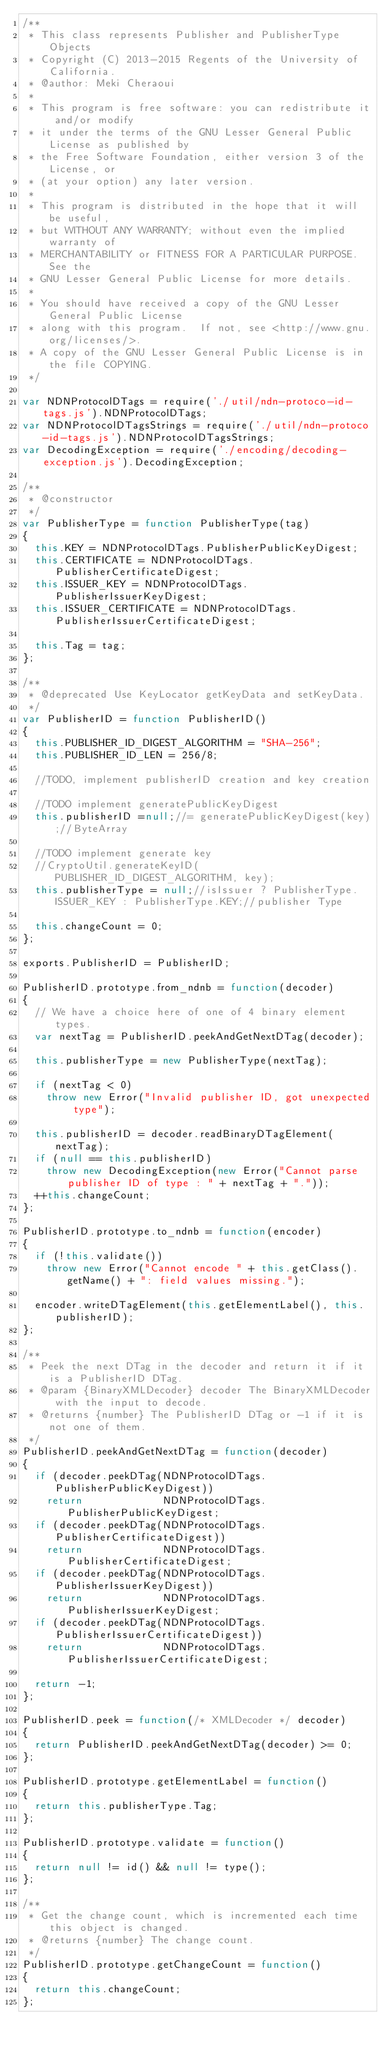Convert code to text. <code><loc_0><loc_0><loc_500><loc_500><_JavaScript_>/**
 * This class represents Publisher and PublisherType Objects
 * Copyright (C) 2013-2015 Regents of the University of California.
 * @author: Meki Cheraoui
 *
 * This program is free software: you can redistribute it and/or modify
 * it under the terms of the GNU Lesser General Public License as published by
 * the Free Software Foundation, either version 3 of the License, or
 * (at your option) any later version.
 *
 * This program is distributed in the hope that it will be useful,
 * but WITHOUT ANY WARRANTY; without even the implied warranty of
 * MERCHANTABILITY or FITNESS FOR A PARTICULAR PURPOSE.  See the
 * GNU Lesser General Public License for more details.
 *
 * You should have received a copy of the GNU Lesser General Public License
 * along with this program.  If not, see <http://www.gnu.org/licenses/>.
 * A copy of the GNU Lesser General Public License is in the file COPYING.
 */

var NDNProtocolDTags = require('./util/ndn-protoco-id-tags.js').NDNProtocolDTags;
var NDNProtocolDTagsStrings = require('./util/ndn-protoco-id-tags.js').NDNProtocolDTagsStrings;
var DecodingException = require('./encoding/decoding-exception.js').DecodingException;

/**
 * @constructor
 */
var PublisherType = function PublisherType(tag)
{
  this.KEY = NDNProtocolDTags.PublisherPublicKeyDigest;
  this.CERTIFICATE = NDNProtocolDTags.PublisherCertificateDigest;
  this.ISSUER_KEY = NDNProtocolDTags.PublisherIssuerKeyDigest;
  this.ISSUER_CERTIFICATE = NDNProtocolDTags.PublisherIssuerCertificateDigest;

  this.Tag = tag;
};

/**
 * @deprecated Use KeyLocator getKeyData and setKeyData.
 */
var PublisherID = function PublisherID()
{
  this.PUBLISHER_ID_DIGEST_ALGORITHM = "SHA-256";
  this.PUBLISHER_ID_LEN = 256/8;

  //TODO, implement publisherID creation and key creation

  //TODO implement generatePublicKeyDigest
  this.publisherID =null;//= generatePublicKeyDigest(key);//ByteArray

  //TODO implement generate key
  //CryptoUtil.generateKeyID(PUBLISHER_ID_DIGEST_ALGORITHM, key);
  this.publisherType = null;//isIssuer ? PublisherType.ISSUER_KEY : PublisherType.KEY;//publisher Type

  this.changeCount = 0;
};

exports.PublisherID = PublisherID;

PublisherID.prototype.from_ndnb = function(decoder)
{
  // We have a choice here of one of 4 binary element types.
  var nextTag = PublisherID.peekAndGetNextDTag(decoder);

  this.publisherType = new PublisherType(nextTag);

  if (nextTag < 0)
    throw new Error("Invalid publisher ID, got unexpected type");

  this.publisherID = decoder.readBinaryDTagElement(nextTag);
  if (null == this.publisherID)
    throw new DecodingException(new Error("Cannot parse publisher ID of type : " + nextTag + "."));
  ++this.changeCount;
};

PublisherID.prototype.to_ndnb = function(encoder)
{
  if (!this.validate())
    throw new Error("Cannot encode " + this.getClass().getName() + ": field values missing.");

  encoder.writeDTagElement(this.getElementLabel(), this.publisherID);
};

/**
 * Peek the next DTag in the decoder and return it if it is a PublisherID DTag.
 * @param {BinaryXMLDecoder} decoder The BinaryXMLDecoder with the input to decode.
 * @returns {number} The PublisherID DTag or -1 if it is not one of them.
 */
PublisherID.peekAndGetNextDTag = function(decoder)
{
  if (decoder.peekDTag(NDNProtocolDTags.PublisherPublicKeyDigest))
    return             NDNProtocolDTags.PublisherPublicKeyDigest;
  if (decoder.peekDTag(NDNProtocolDTags.PublisherCertificateDigest))
    return             NDNProtocolDTags.PublisherCertificateDigest;
  if (decoder.peekDTag(NDNProtocolDTags.PublisherIssuerKeyDigest))
    return             NDNProtocolDTags.PublisherIssuerKeyDigest;
  if (decoder.peekDTag(NDNProtocolDTags.PublisherIssuerCertificateDigest))
    return             NDNProtocolDTags.PublisherIssuerCertificateDigest;

  return -1;
};

PublisherID.peek = function(/* XMLDecoder */ decoder)
{
  return PublisherID.peekAndGetNextDTag(decoder) >= 0;
};

PublisherID.prototype.getElementLabel = function()
{
  return this.publisherType.Tag;
};

PublisherID.prototype.validate = function()
{
  return null != id() && null != type();
};

/**
 * Get the change count, which is incremented each time this object is changed.
 * @returns {number} The change count.
 */
PublisherID.prototype.getChangeCount = function()
{
  return this.changeCount;
};
</code> 